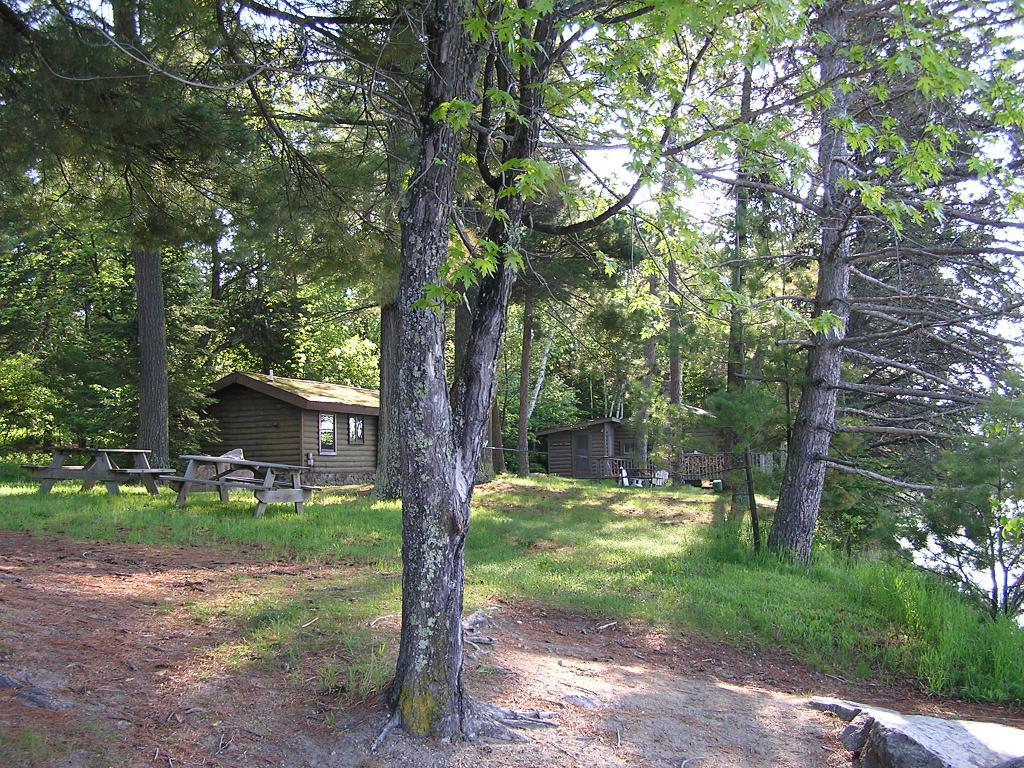What type of vegetation can be seen in the image? There are trees in the image. What type of structure is present in the image? There is a house in the image. What type of seating is available in the image? There are benches in the image. What type of natural ground cover is present in the image? There is grass in the image. What type of natural feature can be seen in the image? There are rocks in the image. What type of water feature is visible in the image? There is water visible in the image. What type of atmospheric feature is visible in the image? There is sky visible in the image. What degree of difficulty is the police officer facing in the image? There is no police officer present in the image, so it is not possible to determine the degree of difficulty they might be facing. 